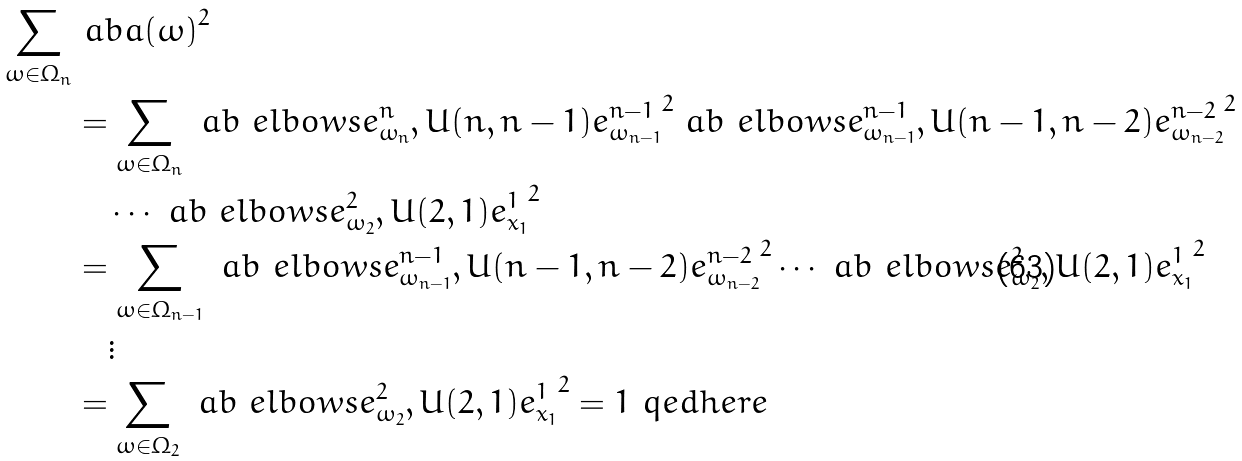Convert formula to latex. <formula><loc_0><loc_0><loc_500><loc_500>\sum _ { \omega \in \Omega _ { n } } & \ a b { a ( \omega ) } ^ { 2 } \\ & = \sum _ { \omega \in \Omega _ { n } } \ a b { \ e l b o w s { e _ { \omega _ { n } } ^ { n } , U ( n , n - 1 ) e _ { \omega _ { n - 1 } } ^ { n - 1 } } } ^ { 2 } \ a b { \ e l b o w s { e _ { \omega _ { n - 1 } } ^ { n - 1 } , U ( n - 1 , n - 2 ) e _ { \omega _ { n - 2 } } ^ { n - 2 } } } ^ { 2 } \\ & \quad \cdots \ a b { \ e l b o w s { e _ { \omega _ { 2 } } ^ { 2 } , U ( 2 , 1 ) e _ { x _ { 1 } } ^ { 1 } } } ^ { 2 } \\ & = \sum _ { \omega \in \Omega _ { n - 1 } } \ a b { \ e l b o w s { e _ { \omega _ { n - 1 } } ^ { n - 1 } , U ( n - 1 , n - 2 ) e _ { \omega _ { n - 2 } } ^ { n - 2 } } } ^ { 2 } \cdots \ a b { \ e l b o w s { e _ { \omega _ { 2 } } ^ { 2 } , U ( 2 , 1 ) e _ { x _ { 1 } } ^ { 1 } } } ^ { 2 } \\ & \quad \vdots \\ & = \sum _ { \omega \in \Omega _ { 2 } } \ a b { \ e l b o w s { e _ { \omega _ { 2 } } ^ { 2 } , U ( 2 , 1 ) e _ { x _ { 1 } } ^ { 1 } } } ^ { 2 } = 1 \ q e d h e r e</formula> 